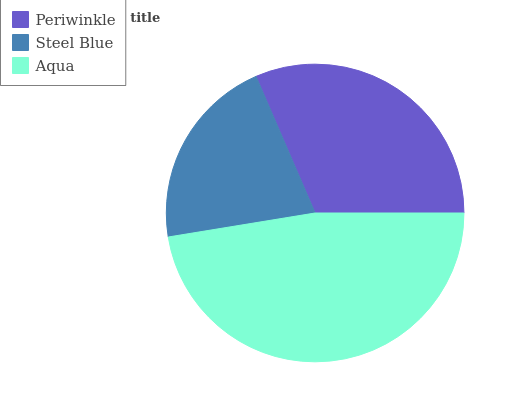Is Steel Blue the minimum?
Answer yes or no. Yes. Is Aqua the maximum?
Answer yes or no. Yes. Is Aqua the minimum?
Answer yes or no. No. Is Steel Blue the maximum?
Answer yes or no. No. Is Aqua greater than Steel Blue?
Answer yes or no. Yes. Is Steel Blue less than Aqua?
Answer yes or no. Yes. Is Steel Blue greater than Aqua?
Answer yes or no. No. Is Aqua less than Steel Blue?
Answer yes or no. No. Is Periwinkle the high median?
Answer yes or no. Yes. Is Periwinkle the low median?
Answer yes or no. Yes. Is Aqua the high median?
Answer yes or no. No. Is Steel Blue the low median?
Answer yes or no. No. 